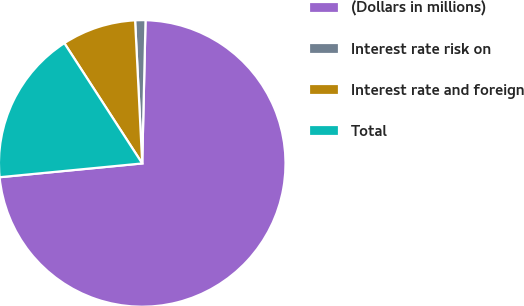<chart> <loc_0><loc_0><loc_500><loc_500><pie_chart><fcel>(Dollars in millions)<fcel>Interest rate risk on<fcel>Interest rate and foreign<fcel>Total<nl><fcel>73.09%<fcel>1.16%<fcel>8.35%<fcel>17.39%<nl></chart> 